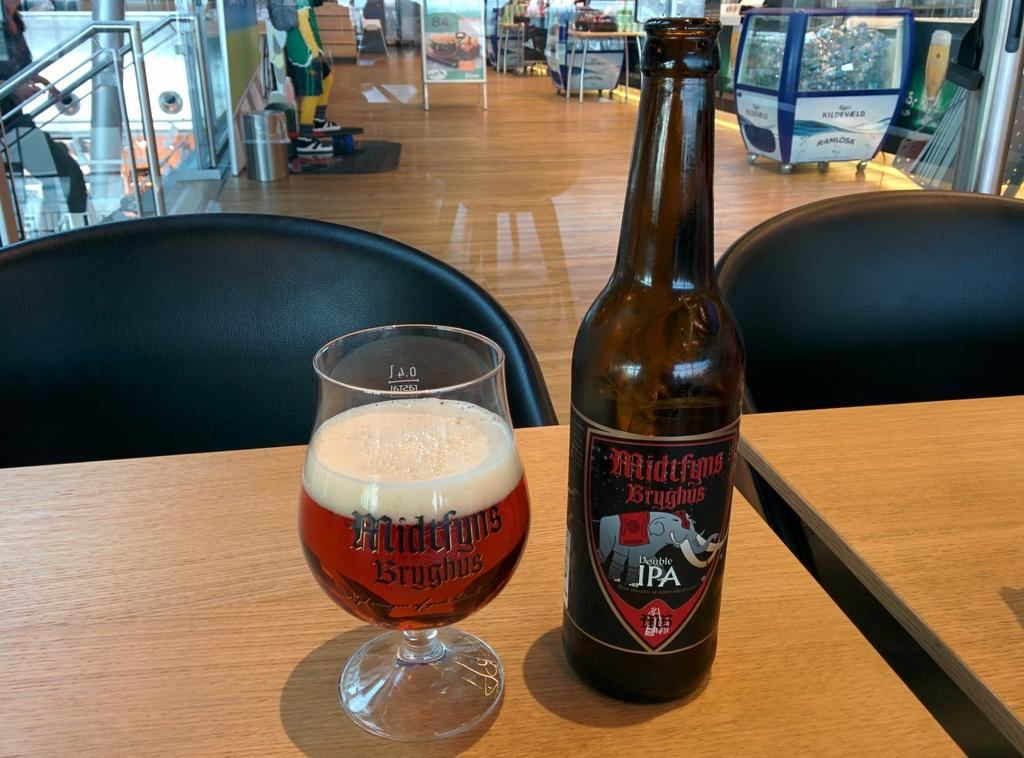Provide a one-sentence caption for the provided image. Bottle of Midtfyns Bryghus" next to a cup of beer. 